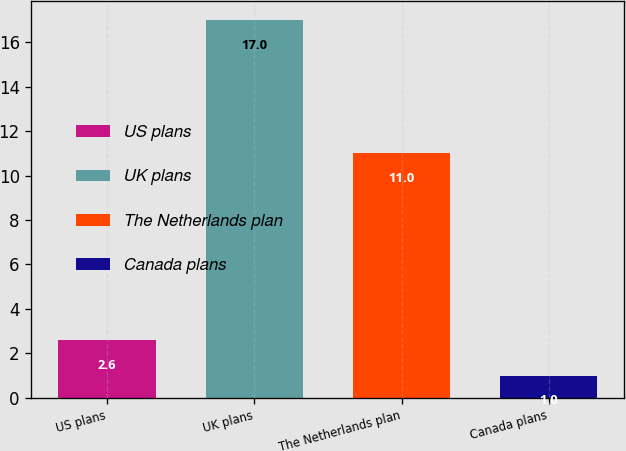<chart> <loc_0><loc_0><loc_500><loc_500><bar_chart><fcel>US plans<fcel>UK plans<fcel>The Netherlands plan<fcel>Canada plans<nl><fcel>2.6<fcel>17<fcel>11<fcel>1<nl></chart> 